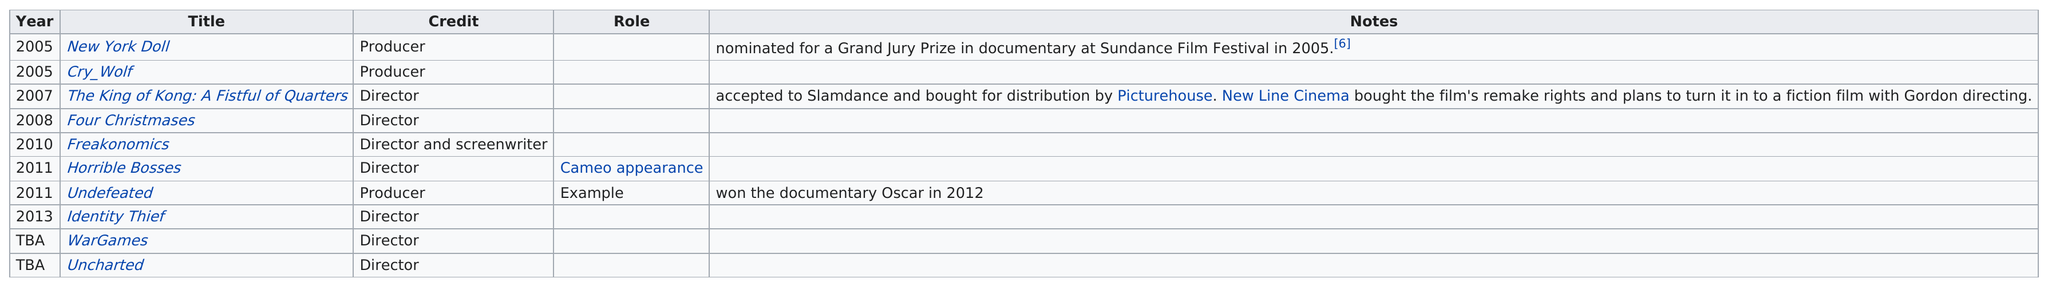Give some essential details in this illustration. The difference in years between 'Cry Wolf' and 'Four Christmases' is three years. The total number of times that the word "director" is listed under the credit column is 7. The earliest known film released was "New York Doll," which was released in 2021. The next title listed after "Cry Wolf" is "The King of Kong: A Fistful of Quarters. In total, there are 10 films. 